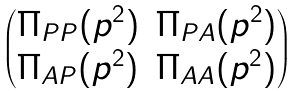<formula> <loc_0><loc_0><loc_500><loc_500>\begin{pmatrix} \Pi _ { P P } ( p ^ { 2 } ) & \Pi _ { P A } ( p ^ { 2 } ) \\ \Pi _ { A P } ( p ^ { 2 } ) & \Pi _ { A A } ( p ^ { 2 } ) \end{pmatrix}</formula> 